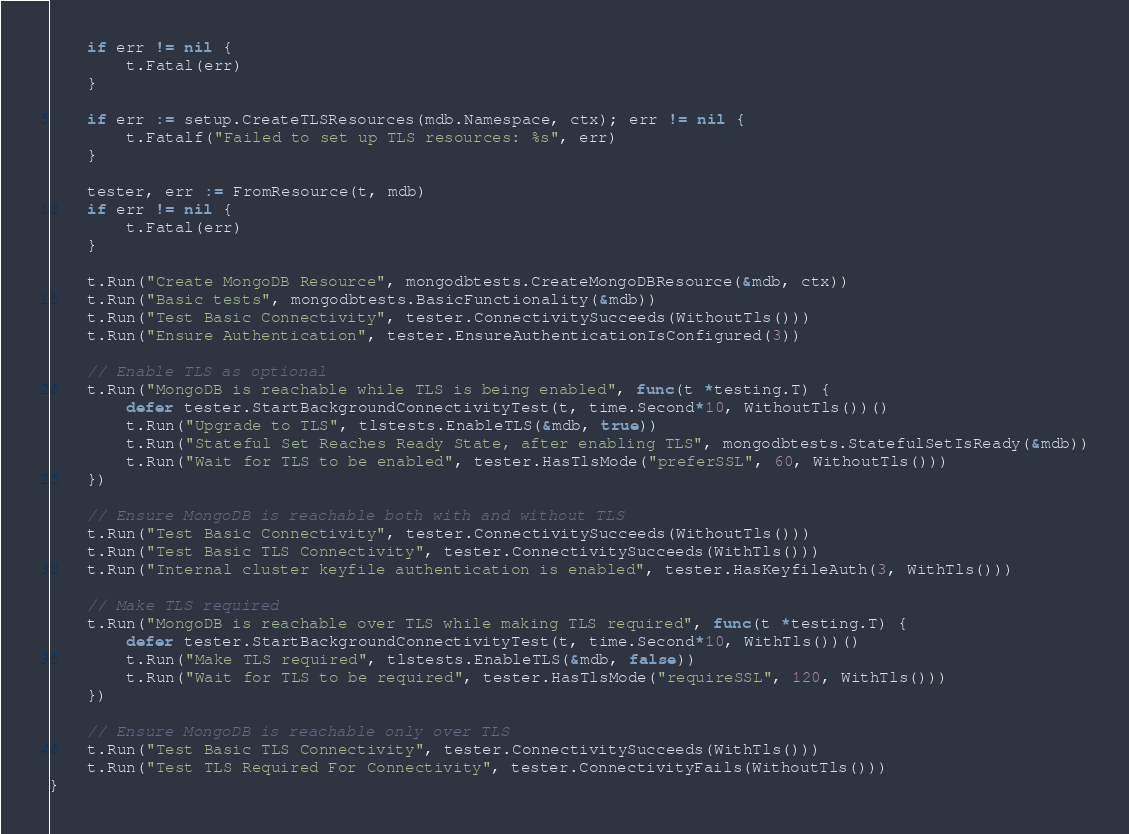<code> <loc_0><loc_0><loc_500><loc_500><_Go_>	if err != nil {
		t.Fatal(err)
	}

	if err := setup.CreateTLSResources(mdb.Namespace, ctx); err != nil {
		t.Fatalf("Failed to set up TLS resources: %s", err)
	}

	tester, err := FromResource(t, mdb)
	if err != nil {
		t.Fatal(err)
	}

	t.Run("Create MongoDB Resource", mongodbtests.CreateMongoDBResource(&mdb, ctx))
	t.Run("Basic tests", mongodbtests.BasicFunctionality(&mdb))
	t.Run("Test Basic Connectivity", tester.ConnectivitySucceeds(WithoutTls()))
	t.Run("Ensure Authentication", tester.EnsureAuthenticationIsConfigured(3))

	// Enable TLS as optional
	t.Run("MongoDB is reachable while TLS is being enabled", func(t *testing.T) {
		defer tester.StartBackgroundConnectivityTest(t, time.Second*10, WithoutTls())()
		t.Run("Upgrade to TLS", tlstests.EnableTLS(&mdb, true))
		t.Run("Stateful Set Reaches Ready State, after enabling TLS", mongodbtests.StatefulSetIsReady(&mdb))
		t.Run("Wait for TLS to be enabled", tester.HasTlsMode("preferSSL", 60, WithoutTls()))
	})

	// Ensure MongoDB is reachable both with and without TLS
	t.Run("Test Basic Connectivity", tester.ConnectivitySucceeds(WithoutTls()))
	t.Run("Test Basic TLS Connectivity", tester.ConnectivitySucceeds(WithTls()))
	t.Run("Internal cluster keyfile authentication is enabled", tester.HasKeyfileAuth(3, WithTls()))

	// Make TLS required
	t.Run("MongoDB is reachable over TLS while making TLS required", func(t *testing.T) {
		defer tester.StartBackgroundConnectivityTest(t, time.Second*10, WithTls())()
		t.Run("Make TLS required", tlstests.EnableTLS(&mdb, false))
		t.Run("Wait for TLS to be required", tester.HasTlsMode("requireSSL", 120, WithTls()))
	})

	// Ensure MongoDB is reachable only over TLS
	t.Run("Test Basic TLS Connectivity", tester.ConnectivitySucceeds(WithTls()))
	t.Run("Test TLS Required For Connectivity", tester.ConnectivityFails(WithoutTls()))
}
</code> 